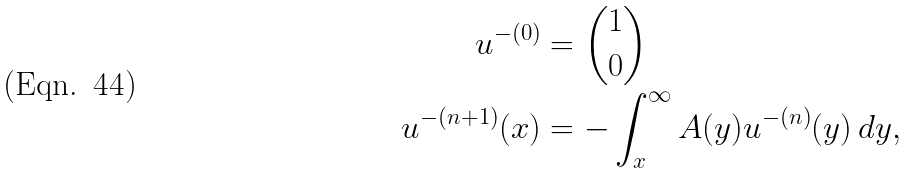<formula> <loc_0><loc_0><loc_500><loc_500>u ^ { - ( 0 ) } & = \binom { 1 } { 0 } \\ u ^ { - ( n + 1 ) } ( x ) & = - \int _ { x } ^ { \infty } A ( y ) u ^ { - ( n ) } ( y ) \, d y ,</formula> 